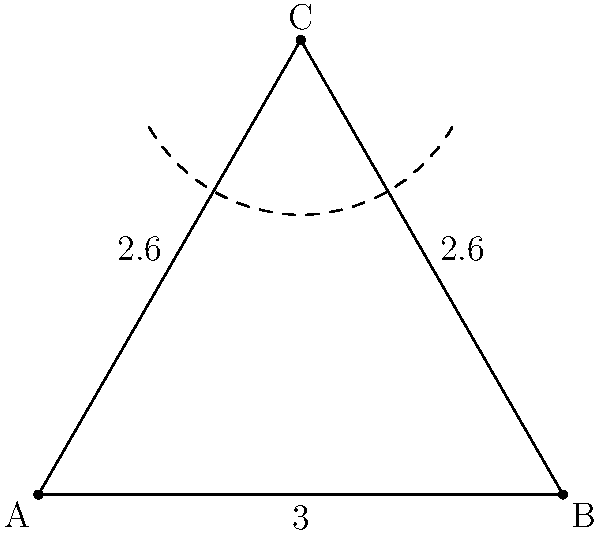In a hyperbolic plane, you're analyzing the efficiency of resource allocation across three market regions represented by a triangle ABC. Given that the side lengths are AB = 3, AC = BC = 2.6 (in hyperbolic units), and the angle at C is 120°, calculate the area of this triangular region using the hyperbolic area formula: $A = \pi - (\alpha + \beta + \gamma)$, where $\alpha$, $\beta$, and $\gamma$ are the angles of the triangle. How does this area compare to what you'd expect in Euclidean geometry, and what implications does this have for resource distribution? To solve this problem, we'll follow these steps:

1) In a hyperbolic triangle, we know that the sum of angles is less than 180°. We're given that angle C is 120°.

2) To find the other two angles, we can use the hyperbolic law of cosines:

   $\cosh c = \cosh a \cosh b - \sinh a \sinh b \cos C$

   Where $a$, $b$, and $c$ are the side lengths opposite to angles $A$, $B$, and $C$ respectively.

3) For angle A:
   $\cosh 2.6 = \cosh 2.6 \cosh 3 - \sinh 2.6 \sinh 3 \cos A$
   
   Solving this, we get: $A \approx 32.8°$

4) For angle B, due to the symmetry of the triangle:
   $B \approx 32.8°$

5) Now we can calculate the area using the formula:
   $A = \pi - (32.8° + 32.8° + 120°) = \pi - 185.6° \approx 0.1396$

6) In Euclidean geometry, this triangle would be impossible as the sum of its angles (185.6°) exceeds 180°.

7) The hyperbolic area is smaller than what we'd expect in Euclidean geometry. This implies that in hyperbolic market regions, resources may need to be distributed differently, as distances and areas behave non-intuitively compared to Euclidean space.
Answer: $0.1396$ hyperbolic square units 